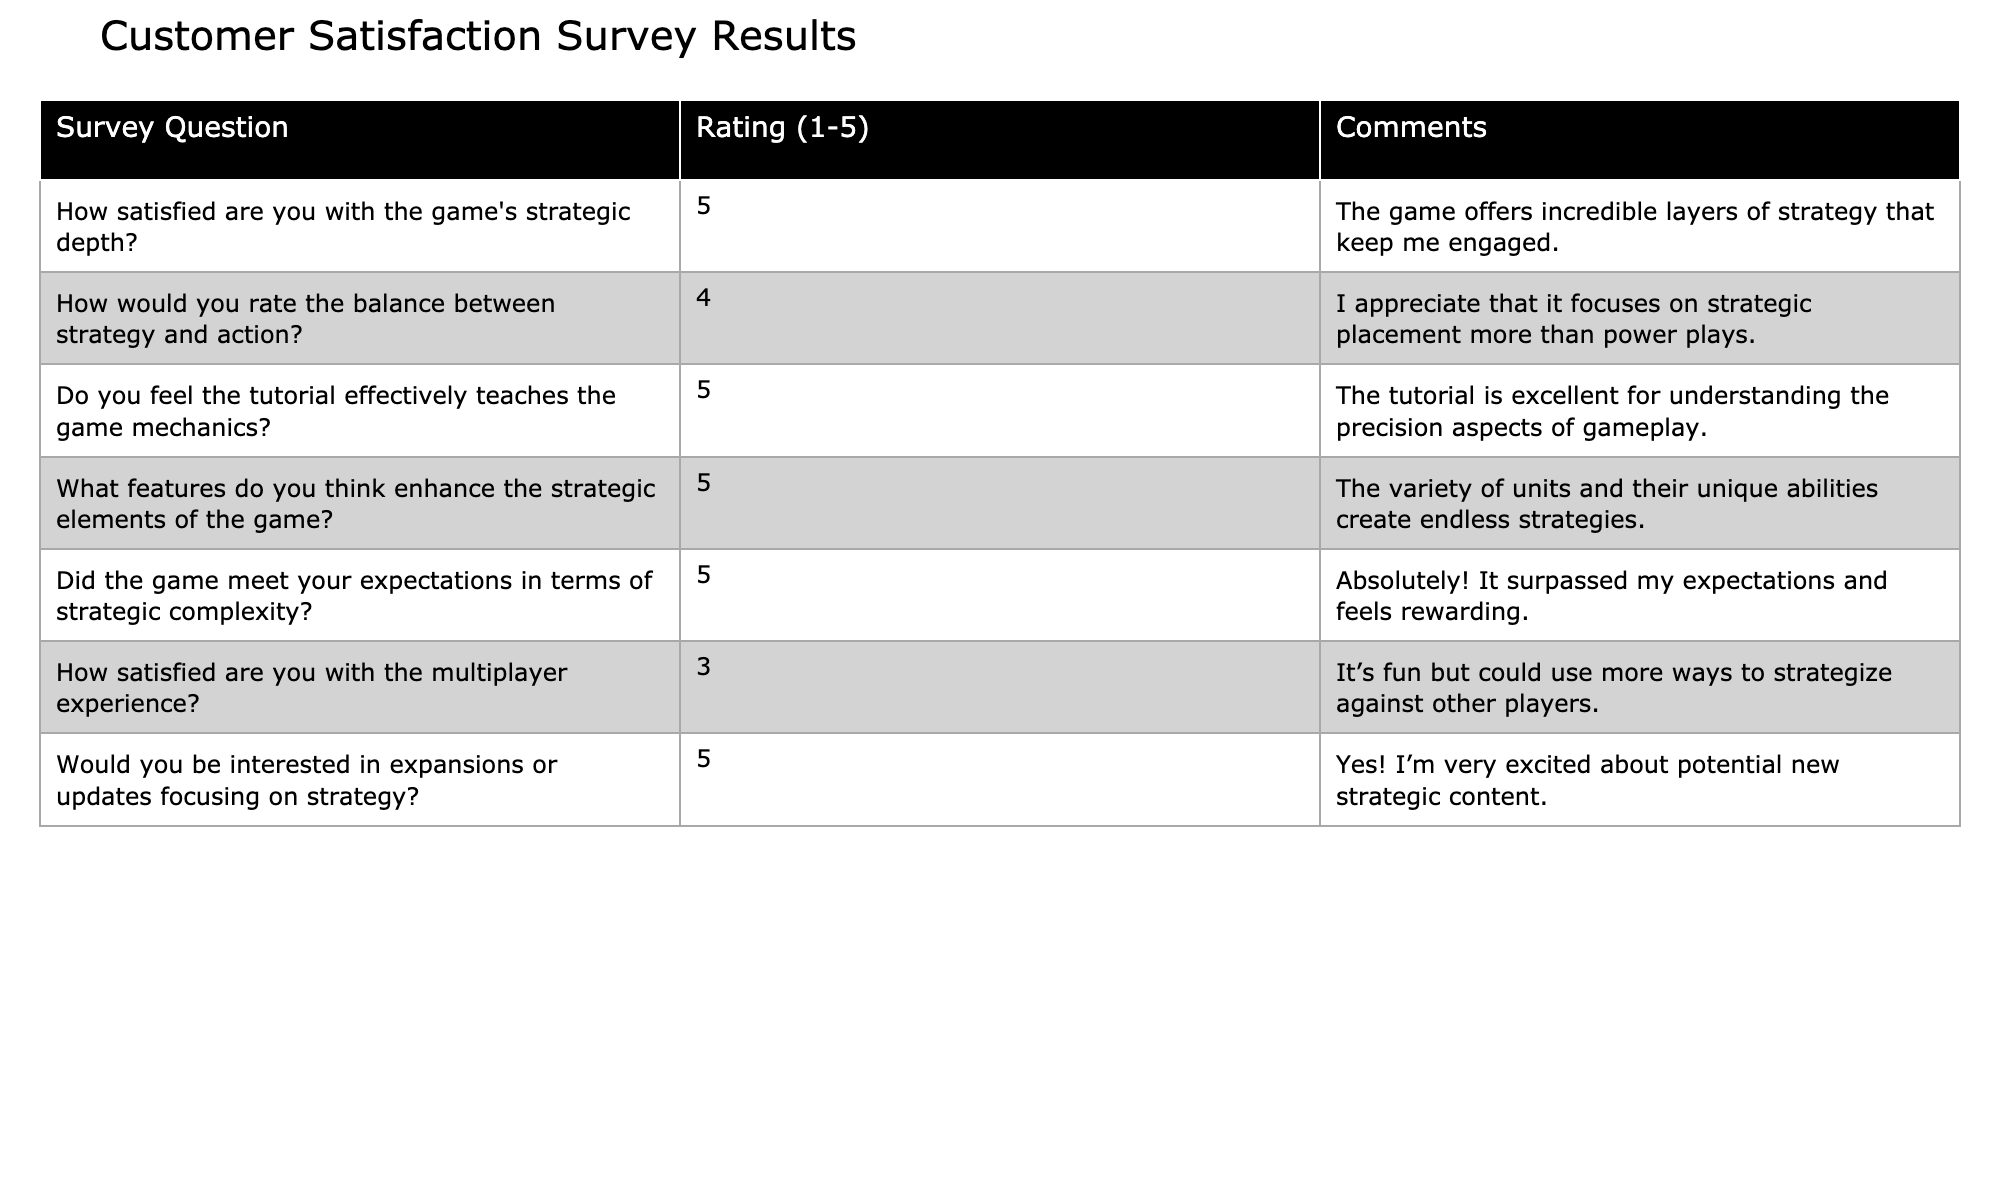What is the highest rating given for customer satisfaction? The highest rating in the table is "5," given for the questions regarding the game's strategic depth, tutorial effectiveness, features enhancing strategic elements, and meeting expectations for strategic complexity.
Answer: 5 What is the average rating for the multiplayer experience? The rating for the multiplayer experience is "3," and since there is only one rating for this category, the average is the same, which is 3.
Answer: 3 Did any features receive a rating of 1 or 2 in the survey? The table shows ratings only range from 3 to 5, and there are no ratings of 1 or 2 provided.
Answer: No Which question had the lowest rating? The lowest rating is "3," which corresponds to the satisfaction with the multiplayer experience.
Answer: Satisfaction with the multiplayer experience What is the sum of the ratings for questions related to strategic aspects of the game? The ratings for the questions about strategic aspects are 5 (strategic depth) + 4 (balance between strategy and action) + 5 (tutorial effectiveness) + 5 (features enhancing strategic elements) + 5 (strategic complexity), which totals 24.
Answer: 24 How many questions received a rating of 5? There are four questions that received a rating of 5, specifically the strategic depth, tutorial effectiveness, features enhancing strategic elements, and meeting expectations for strategic complexity.
Answer: 4 If we exclude the ratings of the multiplayer experience, what would the average rating be? Excluding the multiplayer rating (3), the remaining ratings are 5, 4, 5, 5, and 5. The sum is 24, and there are 5 ratings, so the average is 24/5 = 4.8.
Answer: 4.8 How does the satisfaction rating for the tutorial compare to the rating for the multiplayer experience? The tutorial received a rating of 5, while the multiplayer experience received a rating of 3, meaning the tutorial is rated significantly higher.
Answer: Higher What percentage of the survey responses indicated they would be interested in expansions focusing on strategy? There is one question about interest in expansions rated 5, from a total of 7 responses. To find the percentage: (1/7) * 100 = approximately 14.29%.
Answer: 14.29% 